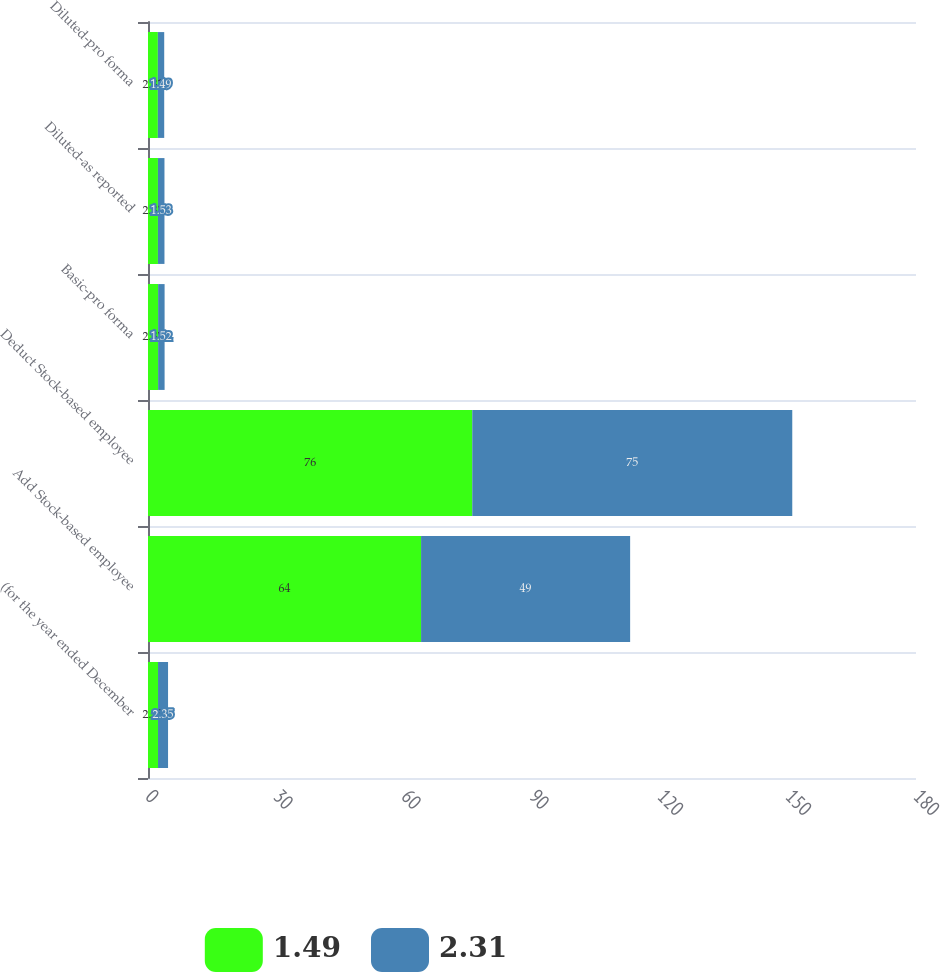Convert chart to OTSL. <chart><loc_0><loc_0><loc_500><loc_500><stacked_bar_chart><ecel><fcel>(for the year ended December<fcel>Add Stock-based employee<fcel>Deduct Stock-based employee<fcel>Basic-pro forma<fcel>Diluted-as reported<fcel>Diluted-pro forma<nl><fcel>1.49<fcel>2.35<fcel>64<fcel>76<fcel>2.37<fcel>2.33<fcel>2.31<nl><fcel>2.31<fcel>2.35<fcel>49<fcel>75<fcel>1.52<fcel>1.53<fcel>1.49<nl></chart> 